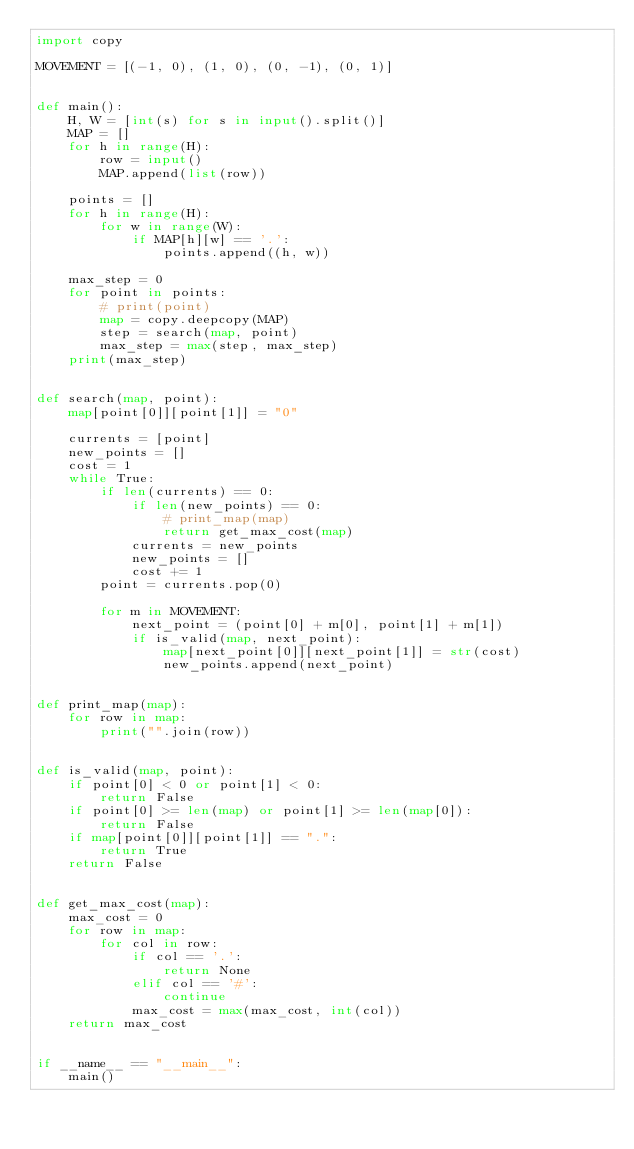<code> <loc_0><loc_0><loc_500><loc_500><_Python_>import copy

MOVEMENT = [(-1, 0), (1, 0), (0, -1), (0, 1)]


def main():
    H, W = [int(s) for s in input().split()]
    MAP = []
    for h in range(H):
        row = input()
        MAP.append(list(row))

    points = []
    for h in range(H):
        for w in range(W):
            if MAP[h][w] == '.':
                points.append((h, w))

    max_step = 0
    for point in points:
        # print(point)
        map = copy.deepcopy(MAP)
        step = search(map, point)
        max_step = max(step, max_step)
    print(max_step)


def search(map, point):
    map[point[0]][point[1]] = "0"

    currents = [point]
    new_points = []
    cost = 1
    while True:
        if len(currents) == 0:
            if len(new_points) == 0:
                # print_map(map)
                return get_max_cost(map)
            currents = new_points
            new_points = []
            cost += 1
        point = currents.pop(0)

        for m in MOVEMENT:
            next_point = (point[0] + m[0], point[1] + m[1])
            if is_valid(map, next_point):
                map[next_point[0]][next_point[1]] = str(cost)
                new_points.append(next_point)


def print_map(map):
    for row in map:
        print("".join(row))


def is_valid(map, point):
    if point[0] < 0 or point[1] < 0:
        return False
    if point[0] >= len(map) or point[1] >= len(map[0]):
        return False
    if map[point[0]][point[1]] == ".":
        return True
    return False


def get_max_cost(map):
    max_cost = 0
    for row in map:
        for col in row:
            if col == '.':
                return None
            elif col == '#':
                continue
            max_cost = max(max_cost, int(col))
    return max_cost


if __name__ == "__main__":
    main()
</code> 